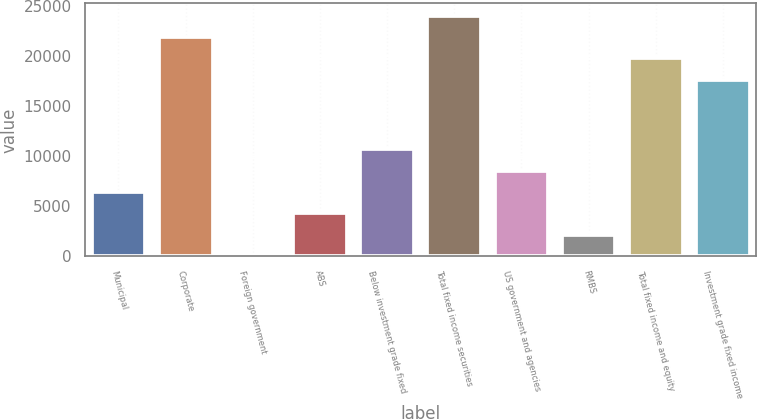Convert chart to OTSL. <chart><loc_0><loc_0><loc_500><loc_500><bar_chart><fcel>Municipal<fcel>Corporate<fcel>Foreign government<fcel>ABS<fcel>Below investment grade fixed<fcel>Total fixed income securities<fcel>US government and agencies<fcel>RMBS<fcel>Total fixed income and equity<fcel>Investment grade fixed income<nl><fcel>6446.6<fcel>21952.4<fcel>20<fcel>4304.4<fcel>10731<fcel>24094.6<fcel>8588.8<fcel>2162.2<fcel>19810.2<fcel>17668<nl></chart> 